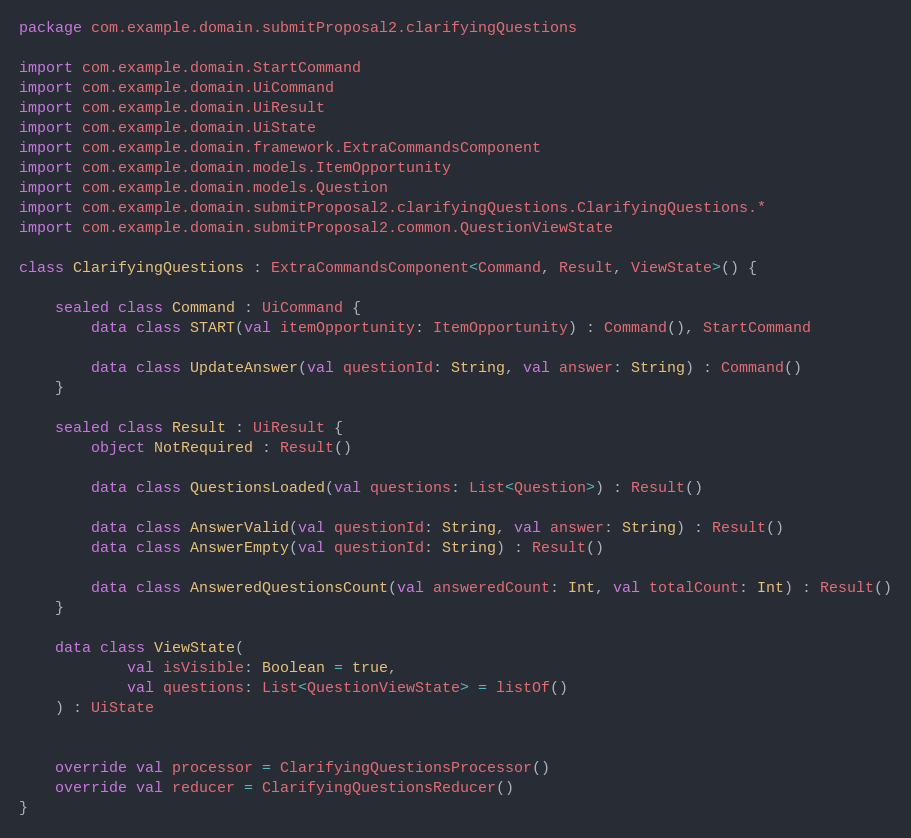Convert code to text. <code><loc_0><loc_0><loc_500><loc_500><_Kotlin_>package com.example.domain.submitProposal2.clarifyingQuestions

import com.example.domain.StartCommand
import com.example.domain.UiCommand
import com.example.domain.UiResult
import com.example.domain.UiState
import com.example.domain.framework.ExtraCommandsComponent
import com.example.domain.models.ItemOpportunity
import com.example.domain.models.Question
import com.example.domain.submitProposal2.clarifyingQuestions.ClarifyingQuestions.*
import com.example.domain.submitProposal2.common.QuestionViewState

class ClarifyingQuestions : ExtraCommandsComponent<Command, Result, ViewState>() {

    sealed class Command : UiCommand {
        data class START(val itemOpportunity: ItemOpportunity) : Command(), StartCommand

        data class UpdateAnswer(val questionId: String, val answer: String) : Command()
    }

    sealed class Result : UiResult {
        object NotRequired : Result()

        data class QuestionsLoaded(val questions: List<Question>) : Result()

        data class AnswerValid(val questionId: String, val answer: String) : Result()
        data class AnswerEmpty(val questionId: String) : Result()

        data class AnsweredQuestionsCount(val answeredCount: Int, val totalCount: Int) : Result()
    }

    data class ViewState(
            val isVisible: Boolean = true,
            val questions: List<QuestionViewState> = listOf()
    ) : UiState


    override val processor = ClarifyingQuestionsProcessor()
    override val reducer = ClarifyingQuestionsReducer()
}
</code> 